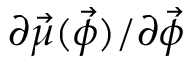<formula> <loc_0><loc_0><loc_500><loc_500>\partial \vec { \mu } ( \vec { \phi } ) / \partial \vec { \phi }</formula> 